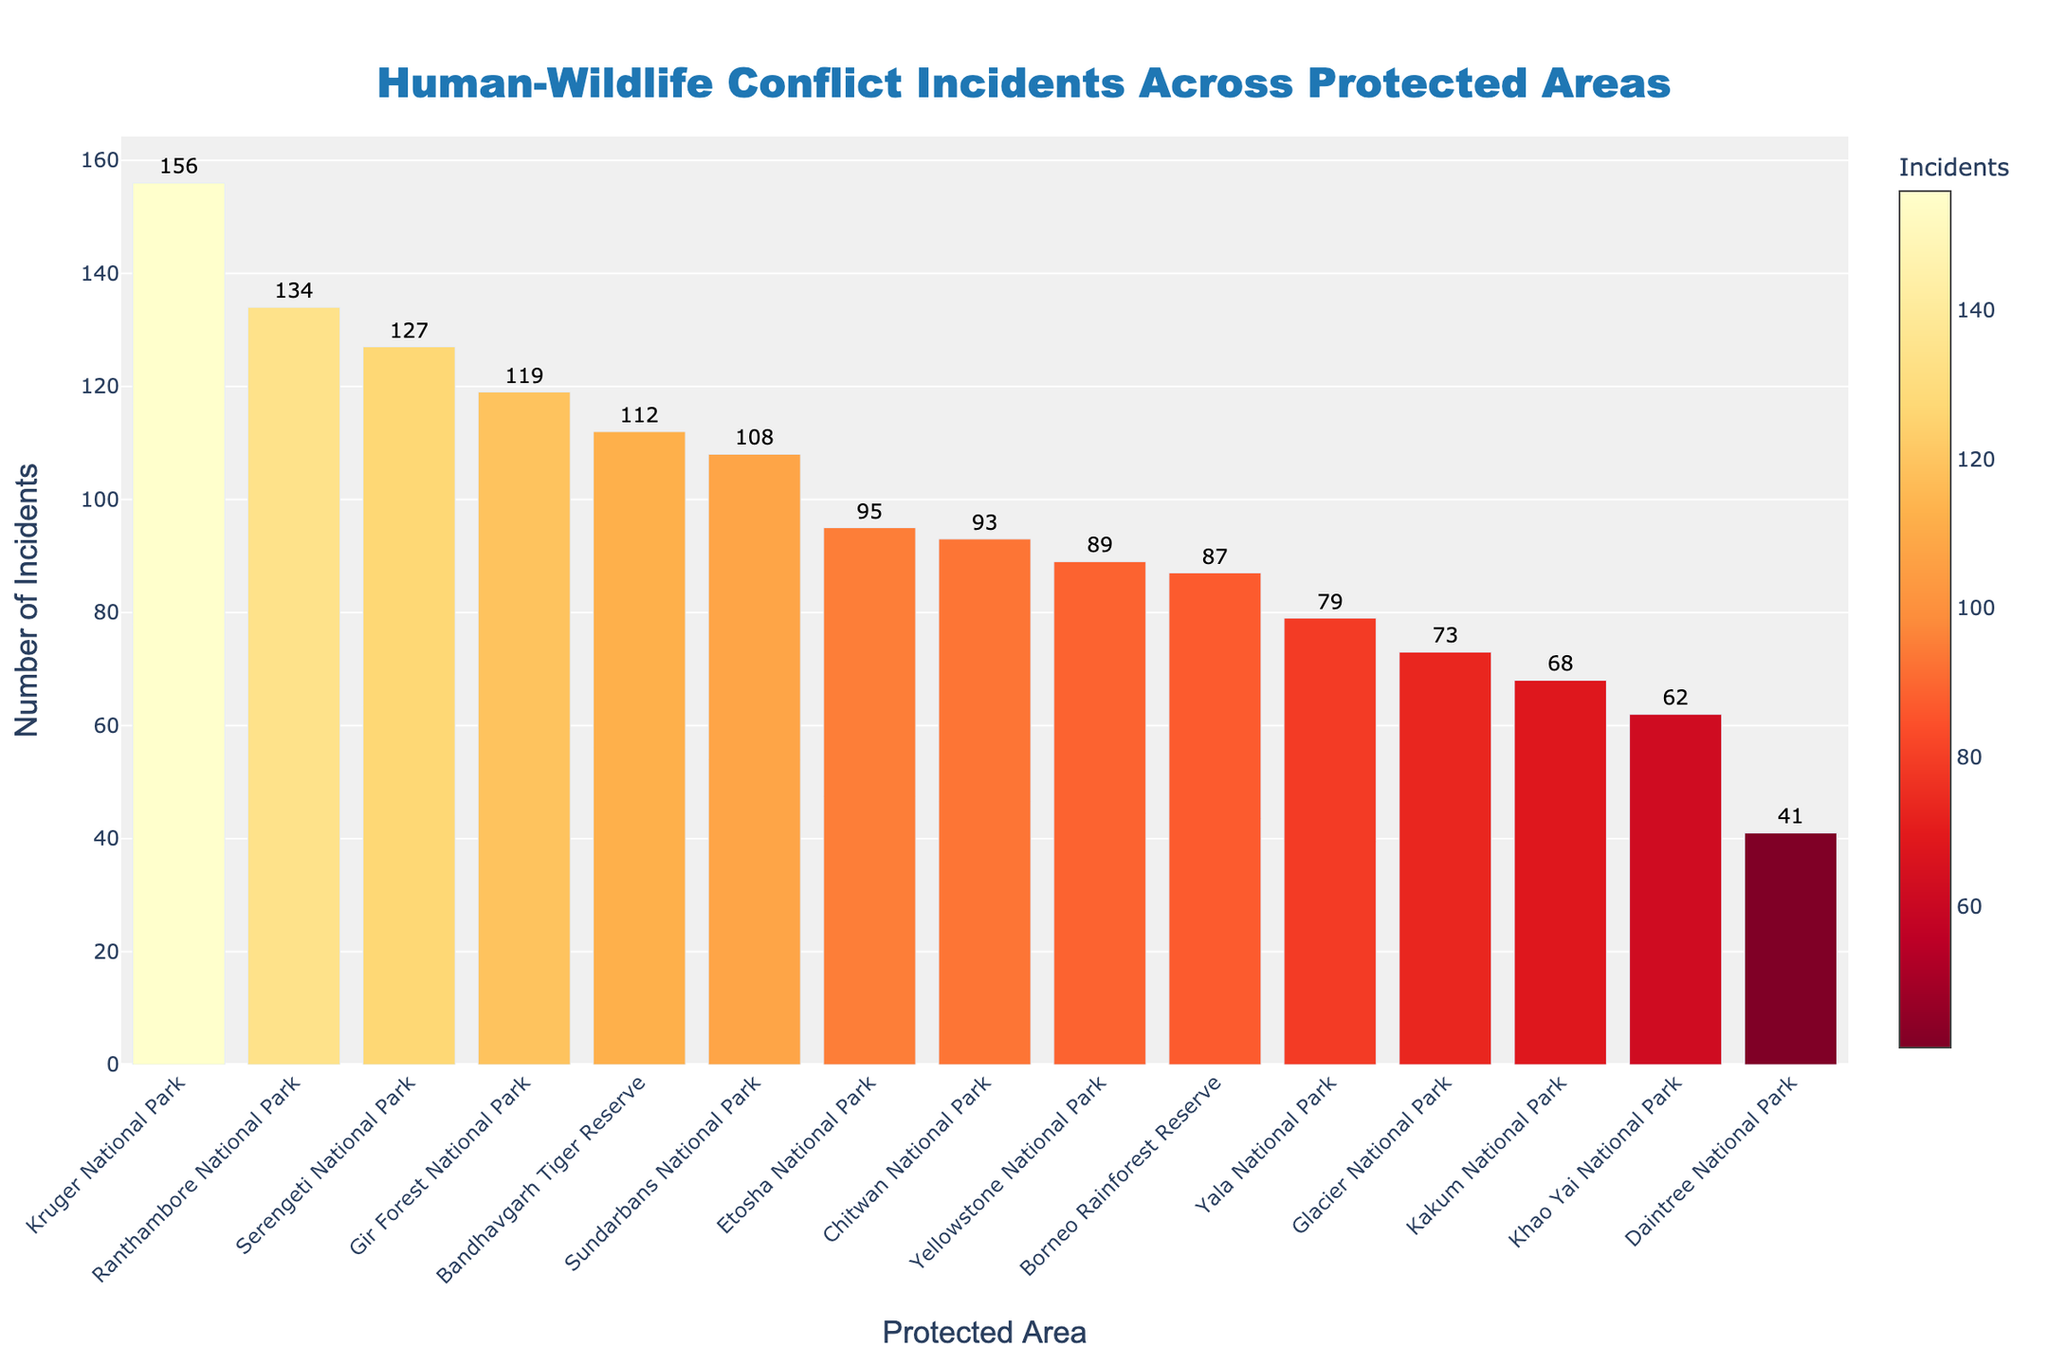what is the difference in the number of human-wildlife conflict incidents between Serengeti National Park and Daintree National Park? Identify the incidents for both parks: Serengeti National Park has 127 incidents, and Daintree National Park has 41 incidents. Subtract the smaller number from the larger: 127 - 41 = 86.
Answer: 86 Which protected area has the highest number of human-wildlife conflict incidents? Look for the bar with the greatest height or check the labels. Kruger National Park has the highest number of incidents at 156.
Answer: Kruger National Park What is the average number of human-wildlife conflict incidents across all protected areas? Sum the incidents for all areas and then divide by the number of areas. Total incidents = 127 + 89 + 156 + 112 + 93 + 68 + 41 + 134 + 79 + 108 + 62 + 95 + 73 + 87 + 119 = 1343. There are 15 areas, so average = 1343 / 15 = 89.53.
Answer: 89.53 How many more incidents does Kruger National Park have compared to Yellowstone National Park? Kruger National Park has 156 incidents, and Yellowstone National Park has 89 incidents. The difference is 156 - 89 = 67.
Answer: 67 Which protected area has the fewest human-wildlife conflict incidents? Look for the shortest bar or the label with the smallest number. Daintree National Park has the fewest incidents at 41.
Answer: Daintree National Park What is the total number of incidents for the five protected areas with the highest incidents? Identify the top five: Kruger (156), Ranthambore (134), Serengeti (127), Gir Forest (119), Bandhavgarh Tiger Reserve (112). Sum them: 156 + 134 + 127 + 119 + 112 = 648.
Answer: 648 Which protected area has slightly fewer incidents than Sundarbans National Park and how many? Sundarbans has 108 incidents. Etosha National Park has slightly fewer with 95 incidents. The difference is 108 - 95 = 13.
Answer: Etosha National Park (13) Is the number of incidents in Serengeti National Park more than double the number in Khao Yai National Park? Serengeti National Park has 127 incidents, and Khao Yai National Park has 62 incidents. Double of 62 is 124. 127 is more than 124.
Answer: Yes What color gradient is used in the bar chart? The description mentions a color gradient that uses a sequence from the YlOrRd palette, which includes shades from yellow to red.
Answer: Yellow to red 